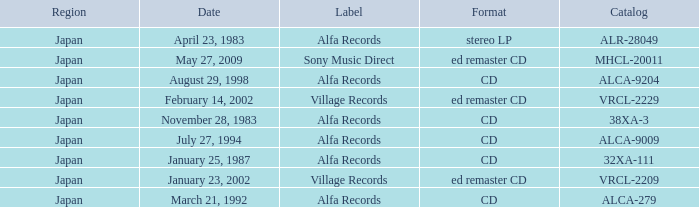Which catalog is in cd format? 38XA-3, 32XA-111, ALCA-279, ALCA-9009, ALCA-9204. 